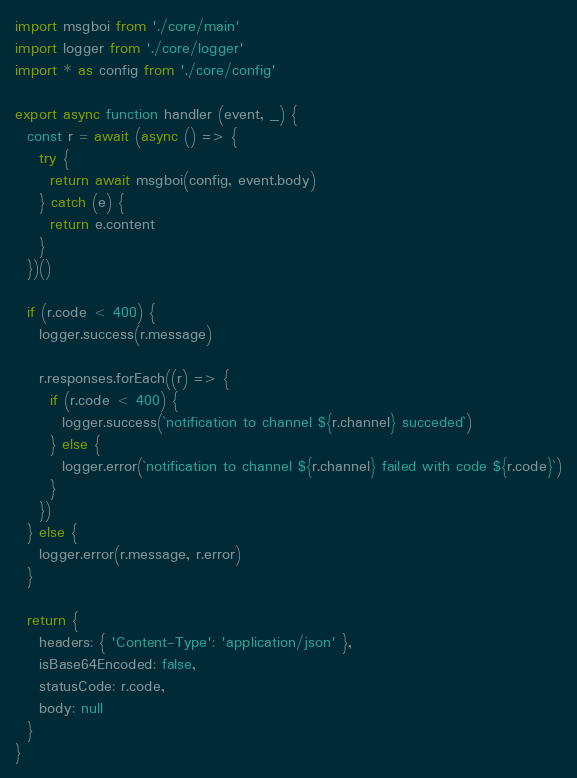<code> <loc_0><loc_0><loc_500><loc_500><_JavaScript_>import msgboi from './core/main'
import logger from './core/logger'
import * as config from './core/config'

export async function handler (event, _) {
  const r = await (async () => {
    try {
      return await msgboi(config, event.body)
    } catch (e) {
      return e.content
    }
  })()

  if (r.code < 400) {
    logger.success(r.message)

    r.responses.forEach((r) => {
      if (r.code < 400) {
        logger.success(`notification to channel ${r.channel} succeded`)
      } else {
        logger.error(`notification to channel ${r.channel} failed with code ${r.code}`)
      }
    })
  } else {
    logger.error(r.message, r.error)
  }

  return {
    headers: { 'Content-Type': 'application/json' },
    isBase64Encoded: false,
    statusCode: r.code,
    body: null
  }
}
</code> 